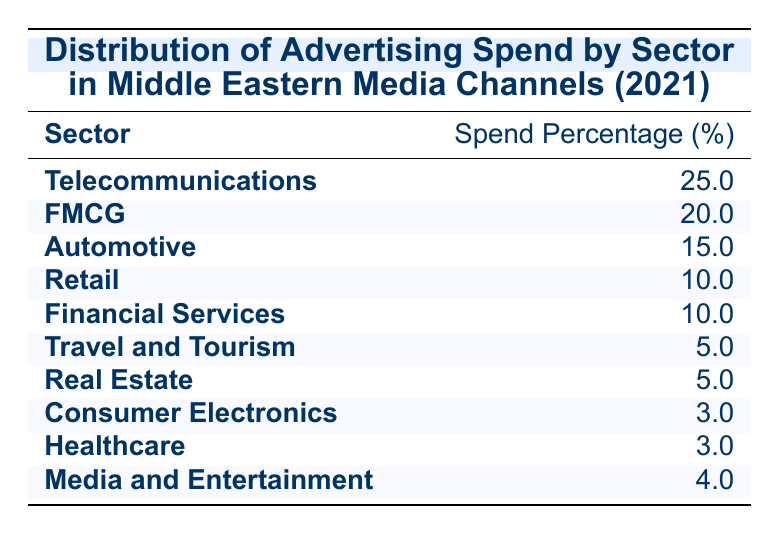What sector has the highest advertising spend percentage? The table shows that Telecommunications has the highest spend percentage at 25.0%.
Answer: Telecommunications Which sector has the same advertising spend percentage as Financial Services? The table indicates that Retail also has a spend percentage of 10.0%, which is the same as Financial Services.
Answer: Retail What is the total advertising spend percentage of the Travel and Tourism and Real Estate sectors combined? The spend percentage for Travel and Tourism is 5.0% and for Real Estate is also 5.0%. Therefore, combining these gives 5.0 + 5.0 = 10.0%.
Answer: 10.0% Is the advertising spend percentage for Media and Entertainment higher than that for Healthcare? The table shows that Media and Entertainment has a spend percentage of 4.0% while Healthcare has 3.0%. Therefore, Media and Entertainment does have a higher percentage.
Answer: Yes What percentage of the total advertising spend is represented by the Automotive, Retail, and Financial Services sectors together? The percentages for Automotive, Retail, and Financial Services are 15.0%, 10.0%, and 10.0% respectively. Adding them gives 15.0 + 10.0 + 10.0 = 35.0%.
Answer: 35.0% 